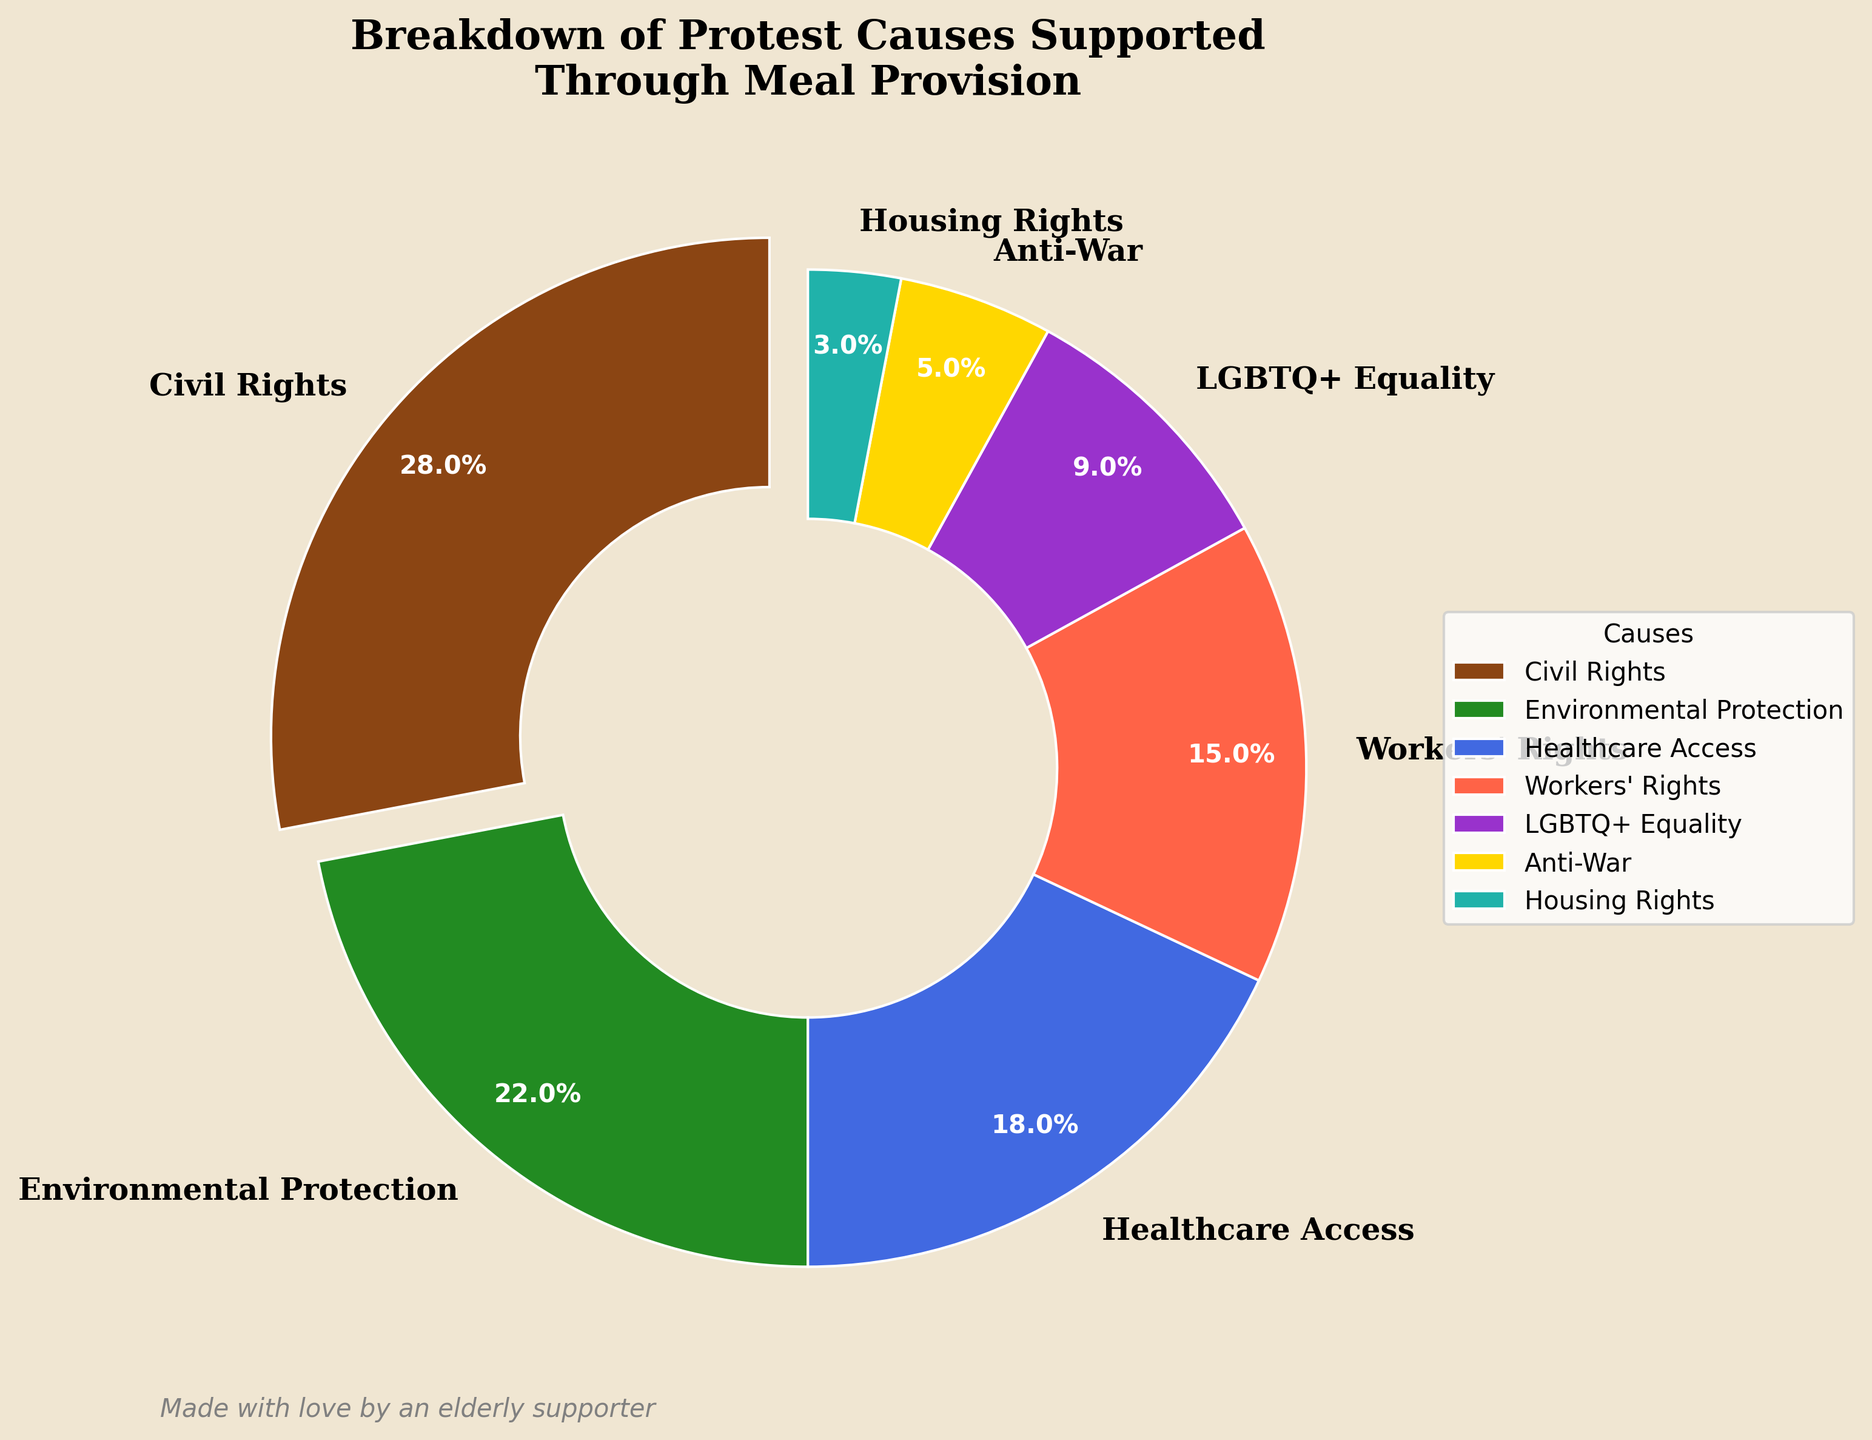What cause received the highest percentage of meal provision support? The wedge with the largest size and an exploded section indicates the cause with the highest percentage.
Answer: Civil Rights How many more percentage points does Civil Rights receive compared to Anti-War? Subtract the percentage for Anti-War from the percentage for Civil Rights. Civil Rights has 28%, and Anti-War has 5%, so the difference is 28 - 5.
Answer: 23 Which causes have percentages that are less than 10%? Identify the causes where the indicated percentages fall below 10%. The causes with percentages less than 10% are LGBTQ+ Equality (9%), Anti-War (5%), and Housing Rights (3%).
Answer: LGBTQ+ Equality, Anti-War, Housing Rights What are the three causes with the least support, and what is their combined percentage? Identify the three causes with the smallest wedges and add their percentages together. The smallest percentages are for Anti-War (5%), Housing Rights (3%), and LGBTQ+ Equality (9%). Adding them gives 5 + 3 + 9.
Answer: Anti-War, Housing Rights, LGBTQ+ Equality; 17% Which cause is represented by the color green, and what percentage does it have? The legend indicates that Environmental Protection is represented by the color green. Refer to the chart for its percentage.
Answer: Environmental Protection; 22% What is the total percentage for causes related to rights (Civil Rights, Workers' Rights, LGBTQ+ Equality, Housing Rights)? Add the percentages for Civil Rights (28%), Workers' Rights (15%), LGBTQ+ Equality (9%), and Housing Rights (3%). The total is 28 + 15 + 9 + 3.
Answer: 55% How does the support for Healthcare Access compare to that of Workers' Rights? Compare the percentages provided for Healthcare Access and Workers' Rights. Healthcare Access has 18%, and Workers' Rights has 15%.
Answer: Healthcare Access has 3% more Between Environmental Protection and Healthcare Access, which cause received more support, and by how much? Compare the percentages of Environmental Protection (22%) and Healthcare Access (18%) and find the difference.
Answer: Environmental Protection by 4% Identify the cause with the smallest wedge and specify its percentage. Look at the wedges' sizes in the pie chart and identify the smallest one. Housing Rights has the smallest wedge.
Answer: Housing Rights; 3% 